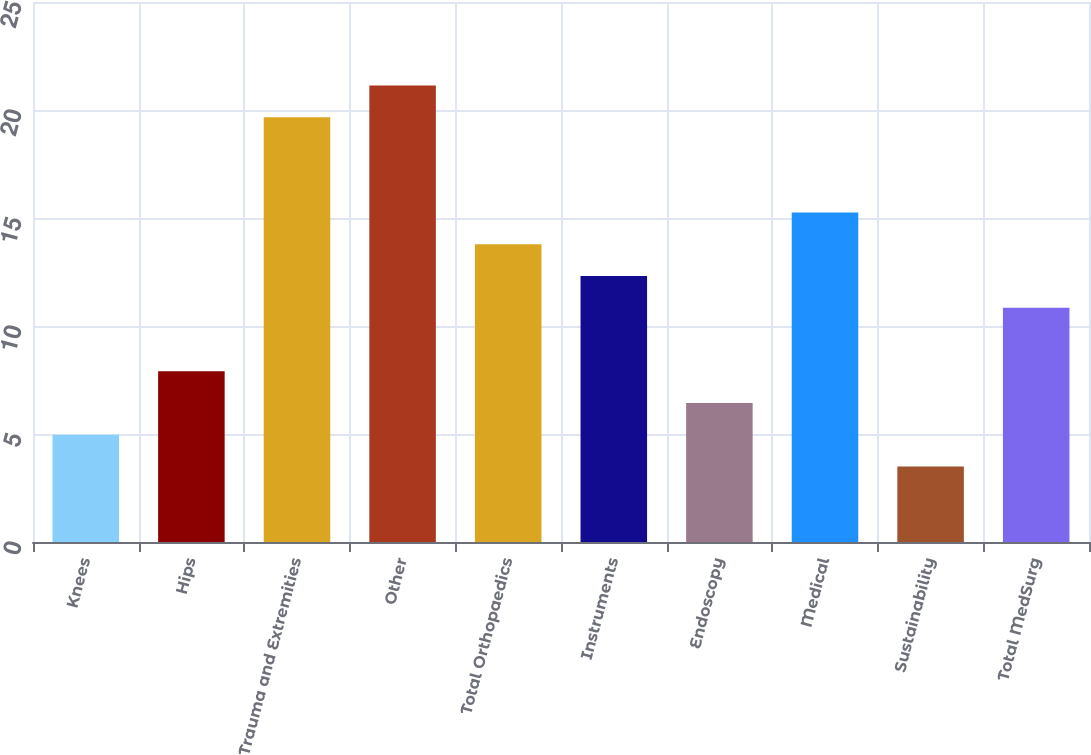<chart> <loc_0><loc_0><loc_500><loc_500><bar_chart><fcel>Knees<fcel>Hips<fcel>Trauma and Extremities<fcel>Other<fcel>Total Orthopaedics<fcel>Instruments<fcel>Endoscopy<fcel>Medical<fcel>Sustainability<fcel>Total MedSurg<nl><fcel>4.97<fcel>7.91<fcel>19.67<fcel>21.14<fcel>13.79<fcel>12.32<fcel>6.44<fcel>15.26<fcel>3.5<fcel>10.85<nl></chart> 